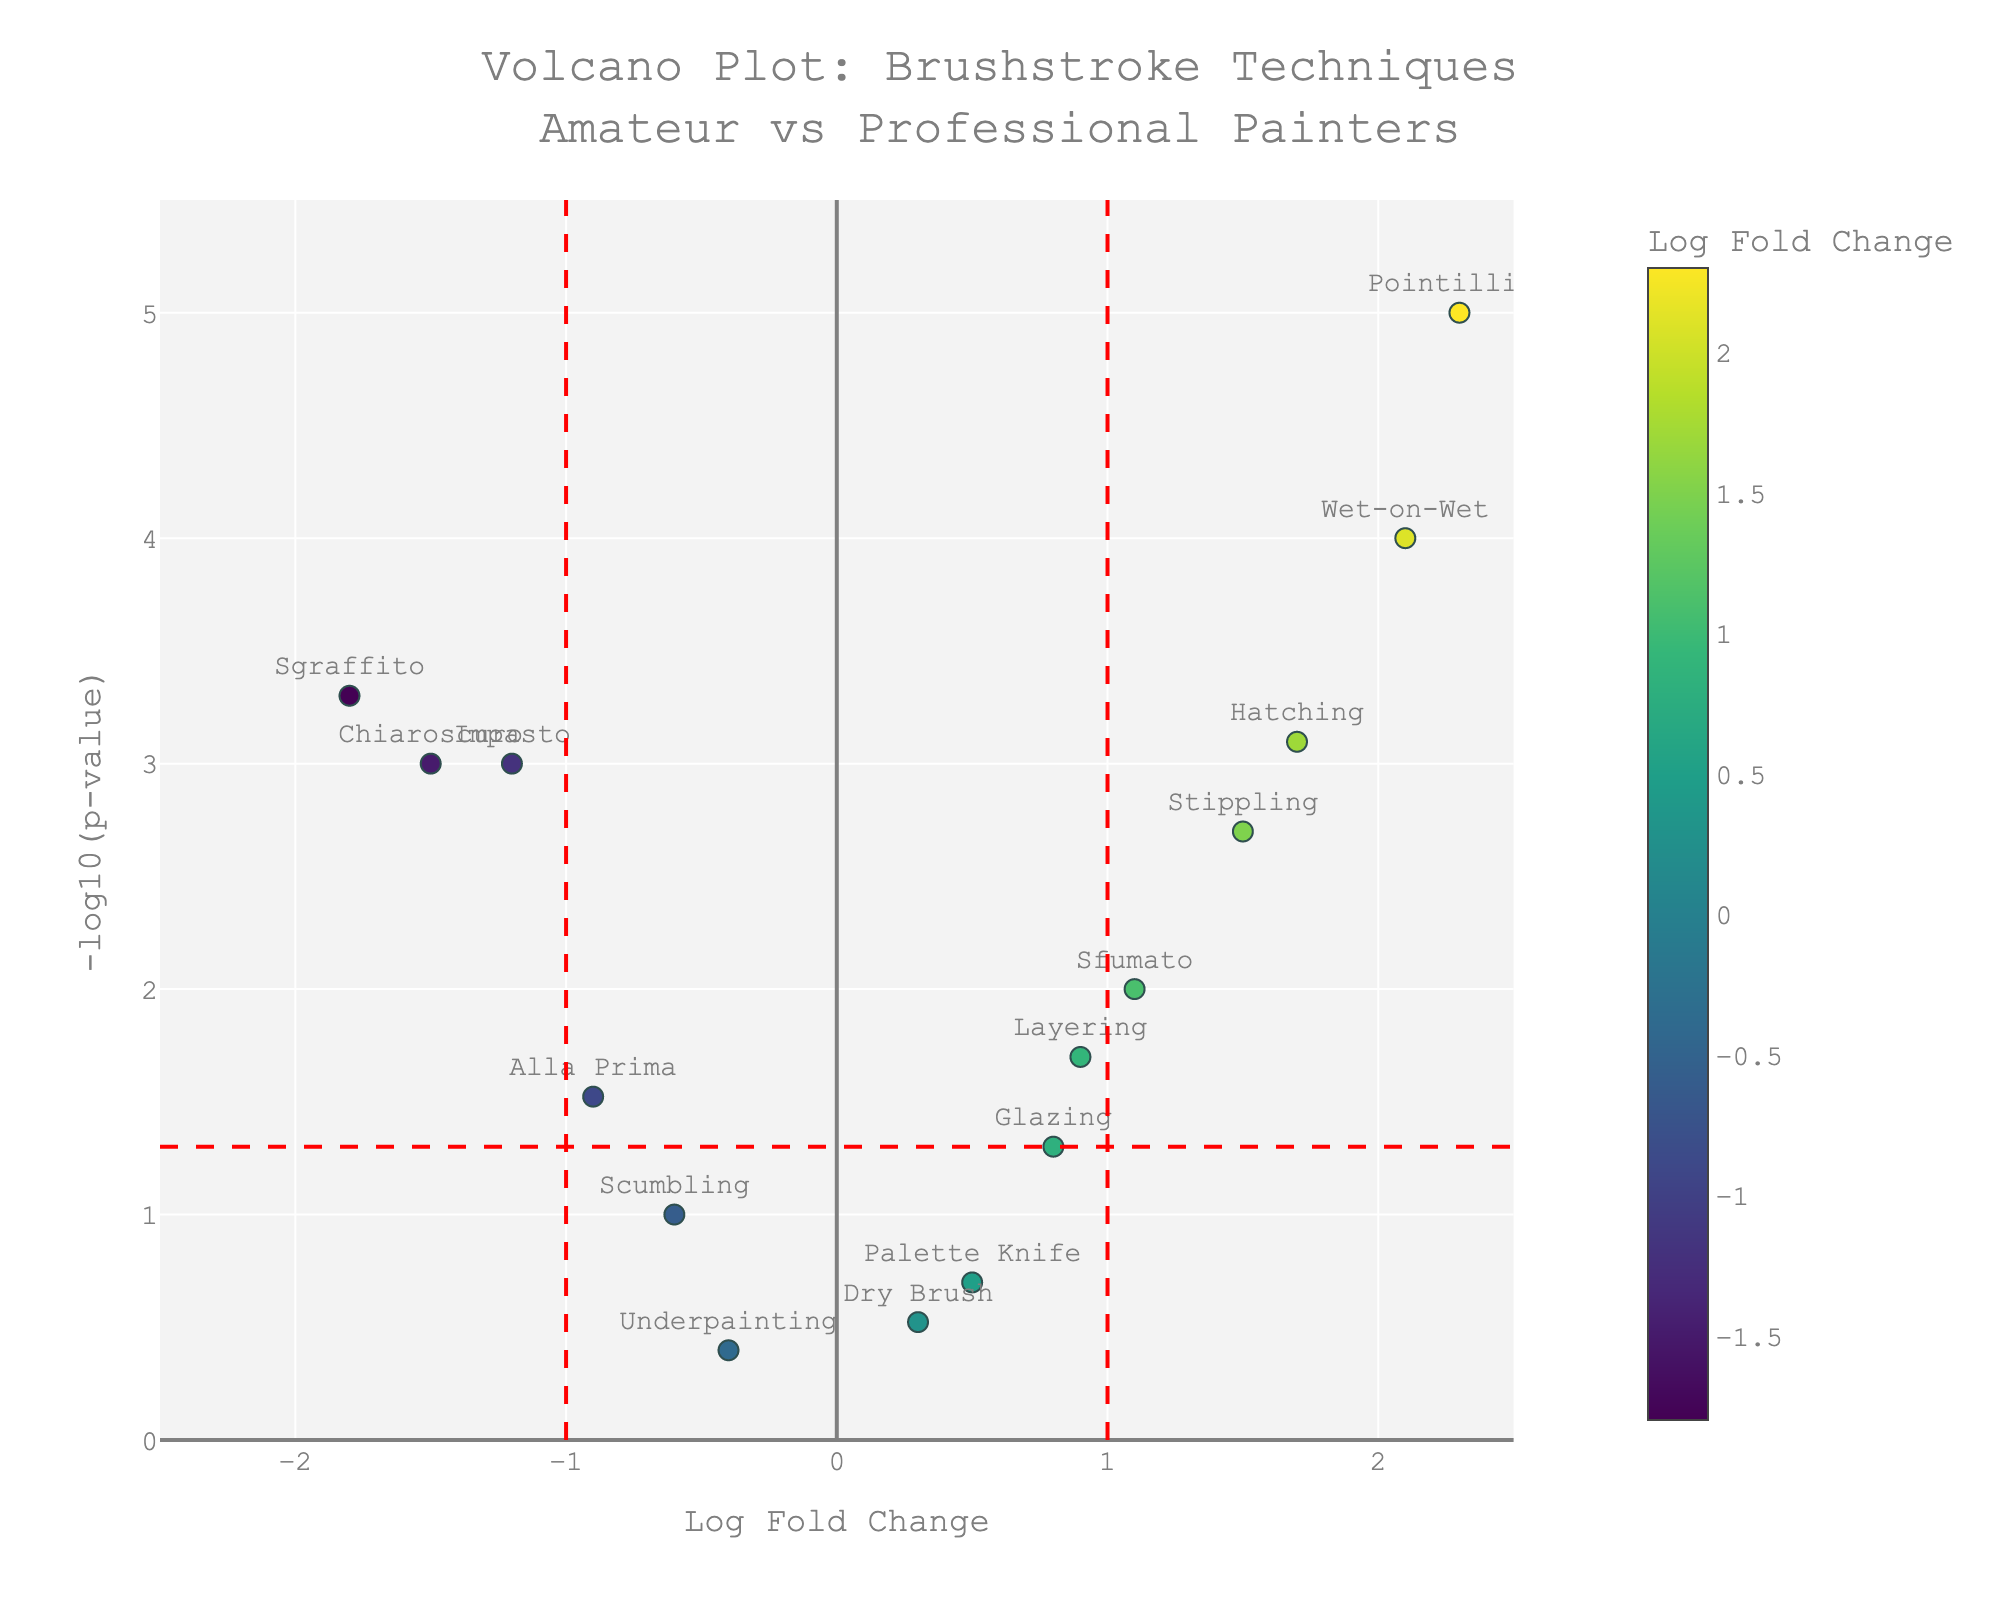What's the title of the plot? The title is displayed at the top of the figure. It is "Volcano Plot: Brushstroke Techniques Amateur vs Professional Painters"
Answer: Volcano Plot: Brushstroke Techniques Amateur vs Professional Painters How many data points are shown in the plot? Each data point represents a brushstroke technique, visualized as a marker. Count the number of distinct markers, which are labeled with the brushstroke technique names. There are 15 brushstroke techniques listed in the data.
Answer: 15 Which brushstroke technique has the highest -log10(p-value)? To identify this, locate the marker at the highest position on the y-axis, which represents the -log10(p-value). The "Pointillism" data point is positioned at the highest point.
Answer: Pointillism Which brushstroke techniques have a negative Log Fold Change below -1 and a significant p-value (p < 0.05)? Determine which data points are situated to the left of the -1 line on the x-axis and above the horizontal line representing the threshold at -log10(0.05). The techniques Impasto, Sgraffito, and Chiaroscuro fit these criteria.
Answer: Impasto, Sgraffito, Chiaroscuro What is the Log Fold Change and p-value of the "Wet-on-Wet" brushstroke technique? Hover over the corresponding marker or refer to the detailed hover text for "Wet-on-Wet." The figure indicates "Wet-on-Wet<br>Log Fold Change: 2.10<br>p-value: 0.0001".
Answer: Log Fold Change: 2.1, p-value: 0.0001 Which brushstroke techniques indicate differences (Log Fold Change ≥ 1 or ≤ -1) and are statistically significant (p < 0.05)? Locate the data points to the far left or right (Log Fold Change ≥ 1 or ≤ -1) and those whose p-values place them above the horizontal line at -log10(0.05). These points are Impasto, Stippling, Wet-on-Wet, Sgraffito, Chiaroscuro, Pointillism, and Hatching.
Answer: Impasto, Stippling, Wet-on-Wet, Sgraffito, Chiaroscuro, Pointillism, Hatching Which technique exhibits the smallest Log Fold Change but has a significant p-value (p < 0.05)? Examine the markers to the farthest left but above the horizontal line indicating p < 0.05. "Sgraffito" with a Log Fold Change of -1.8 and p-value of 0.0005 fits this criterion.
Answer: Sgraffito How many techniques have Log Fold Changes between -1 and 1 and are not statistically significant (p ≥ 0.05)? Identify the markers within the range -1 < Log Fold Change < 1 and below the horizontal line at -log10(0.05). These techniques include Glazing, Scumbling, Dry Brush, Palette Knife, and Underpainting, totalling 5.
Answer: 5 